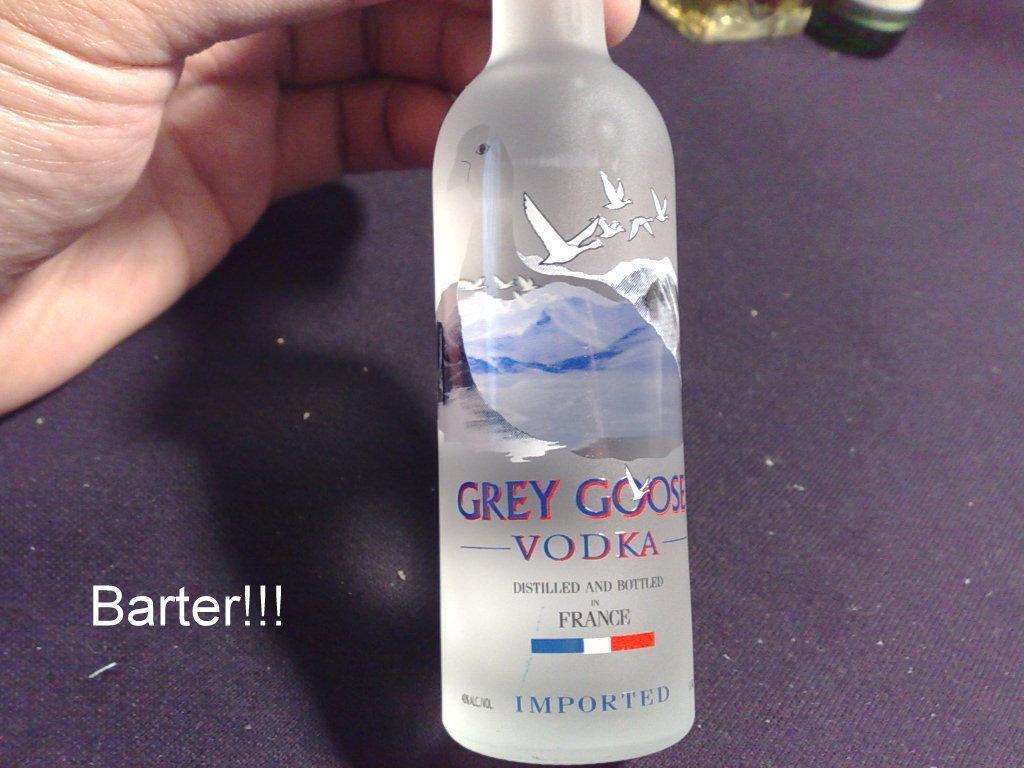Can you describe this image briefly? In this picture we can see a bottle and a person hand on a platform and on bottle we can see mountains, birds. 